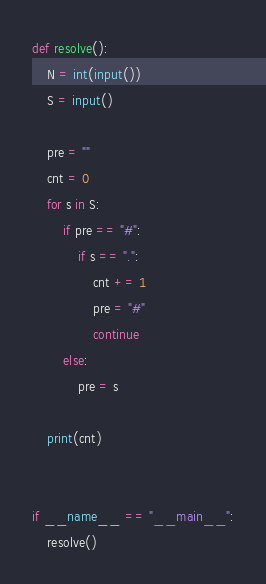Convert code to text. <code><loc_0><loc_0><loc_500><loc_500><_Python_>
def resolve():
    N = int(input())
    S = input()

    pre = ""
    cnt = 0
    for s in S:
        if pre == "#":
            if s == ".":
                cnt += 1
                pre = "#"
                continue
        else:
            pre = s

    print(cnt)


if __name__ == "__main__":
    resolve()</code> 